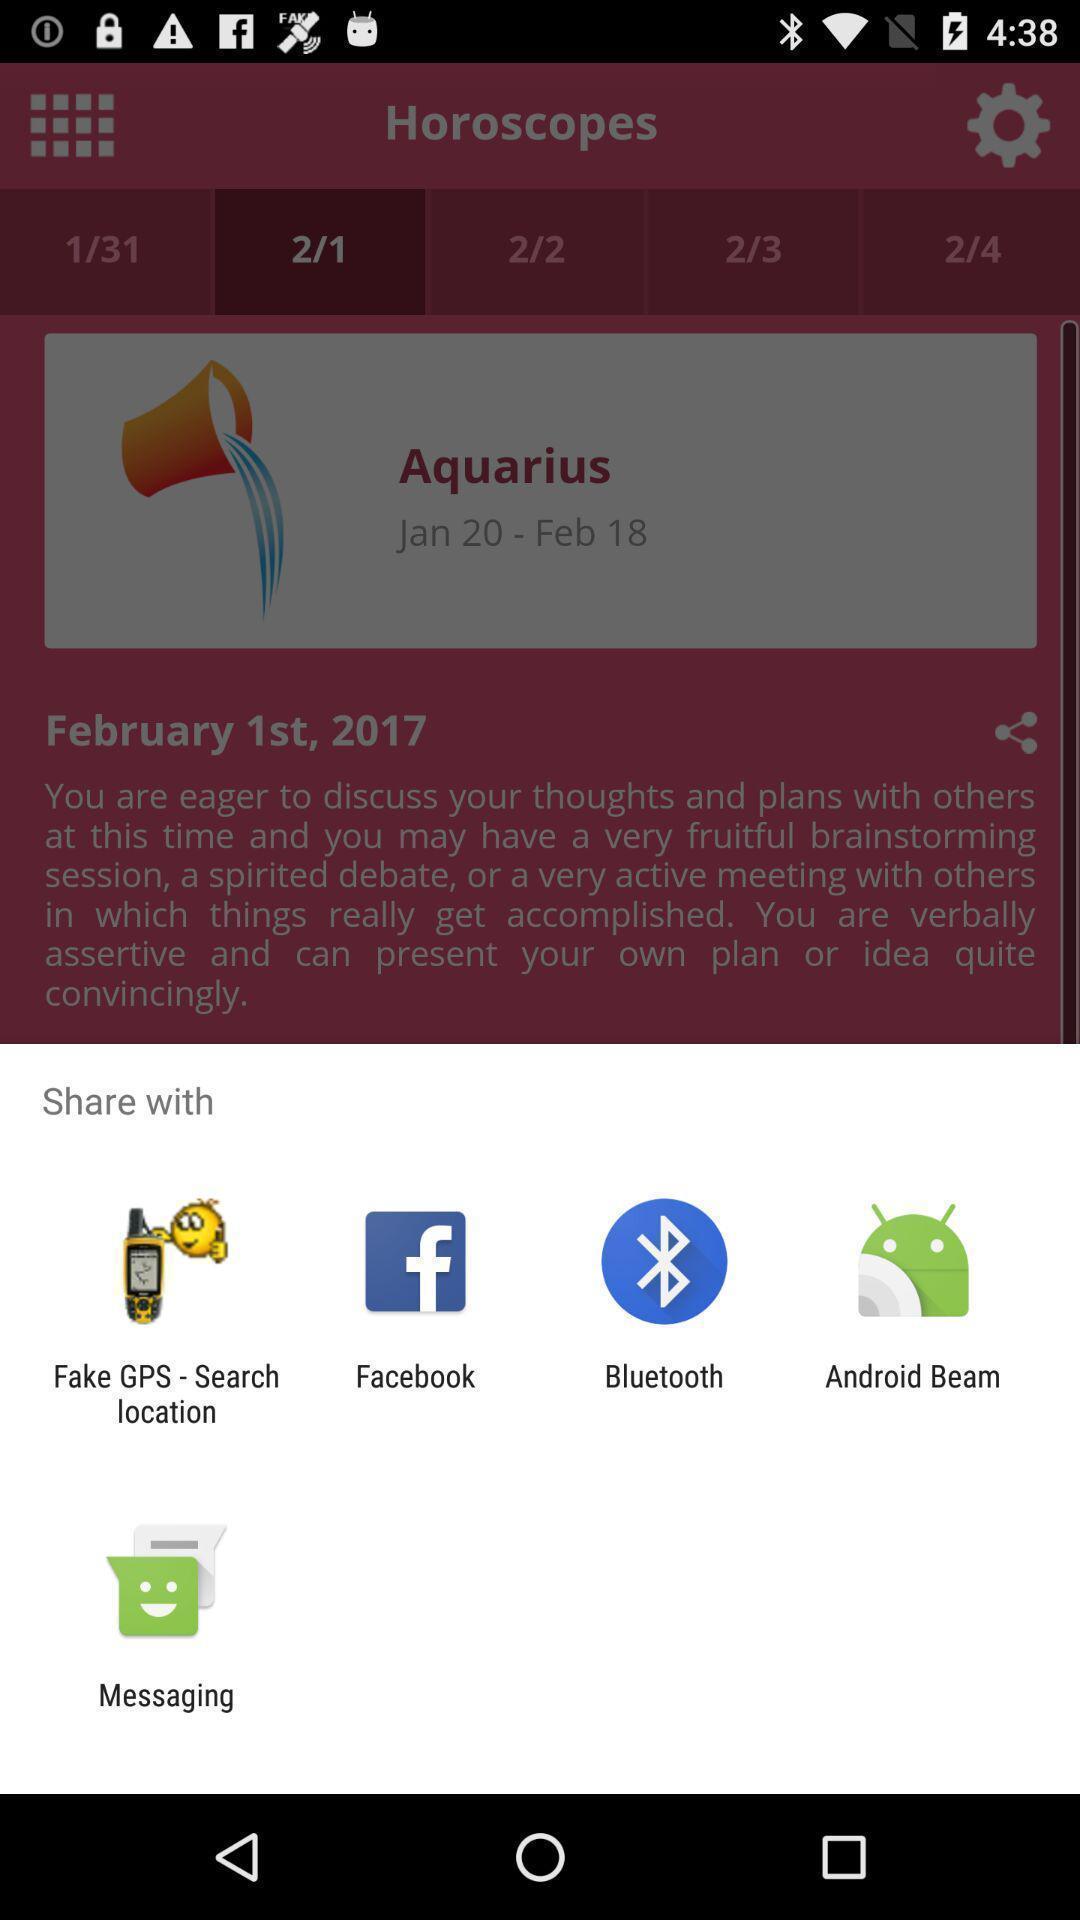Describe the key features of this screenshot. Screen shows share option with multiple applications. 